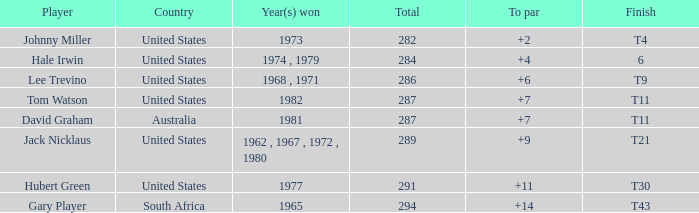How many total wins were achieved in 1982? 287.0. 